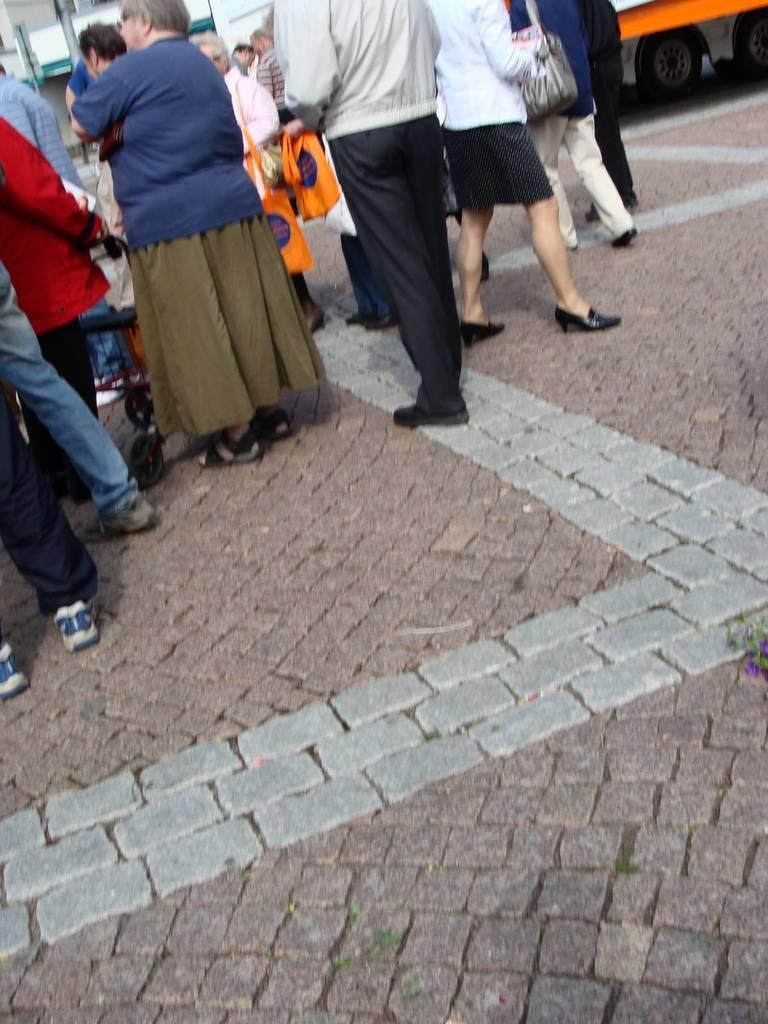Could you give a brief overview of what you see in this image? In this image we can see few persons are standing on the footpath and among them few persons are holding bags and there is a cart wheel. In the background we can see poles, wall, vehicle and objects. 